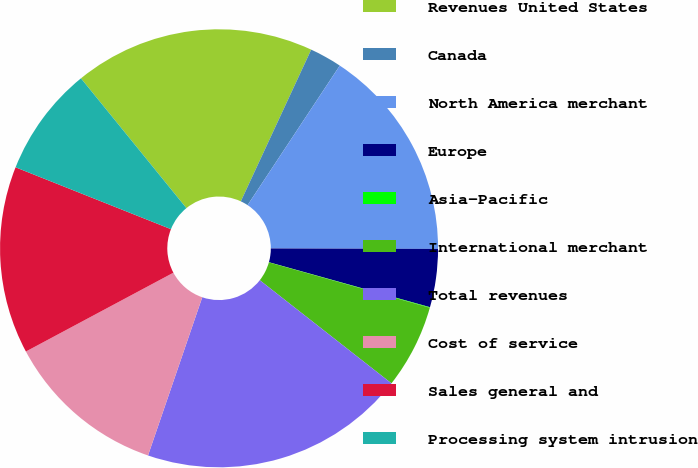Convert chart. <chart><loc_0><loc_0><loc_500><loc_500><pie_chart><fcel>Revenues United States<fcel>Canada<fcel>North America merchant<fcel>Europe<fcel>Asia-Pacific<fcel>International merchant<fcel>Total revenues<fcel>Cost of service<fcel>Sales general and<fcel>Processing system intrusion<nl><fcel>17.77%<fcel>2.38%<fcel>15.75%<fcel>4.29%<fcel>0.04%<fcel>6.2%<fcel>19.68%<fcel>11.93%<fcel>13.84%<fcel>8.11%<nl></chart> 